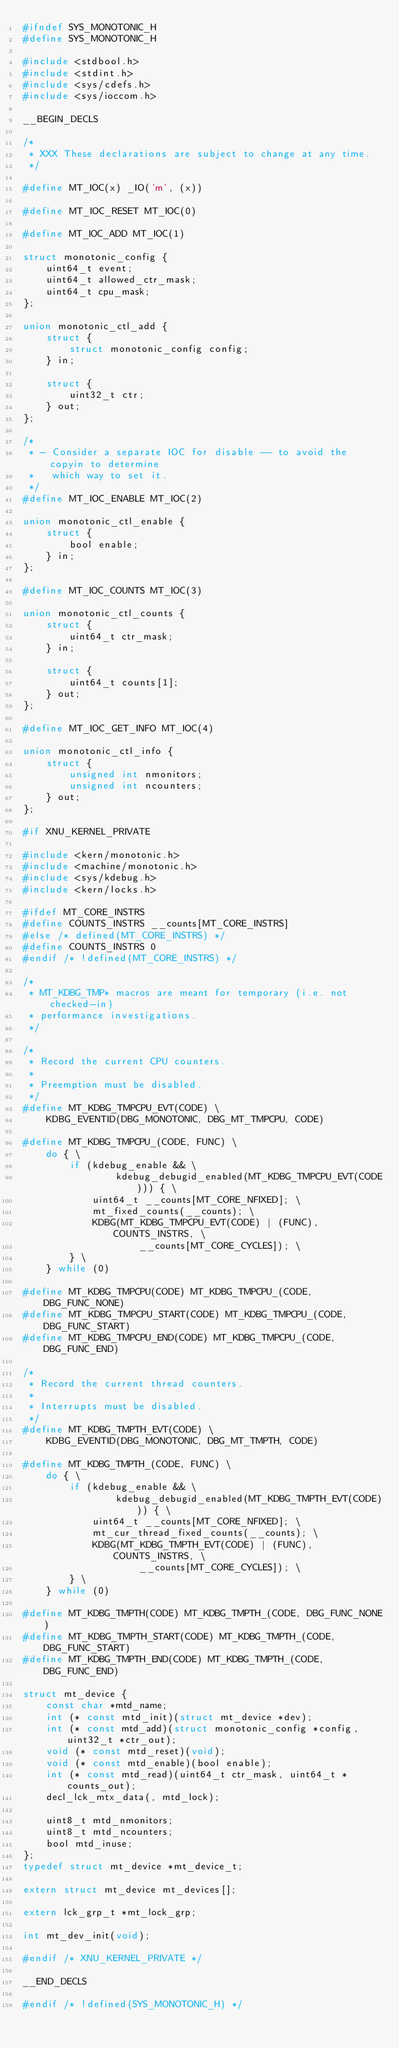Convert code to text. <code><loc_0><loc_0><loc_500><loc_500><_C_>#ifndef SYS_MONOTONIC_H
#define SYS_MONOTONIC_H

#include <stdbool.h>
#include <stdint.h>
#include <sys/cdefs.h>
#include <sys/ioccom.h>

__BEGIN_DECLS

/*
 * XXX These declarations are subject to change at any time.
 */

#define MT_IOC(x) _IO('m', (x))

#define MT_IOC_RESET MT_IOC(0)

#define MT_IOC_ADD MT_IOC(1)

struct monotonic_config {
	uint64_t event;
	uint64_t allowed_ctr_mask;
	uint64_t cpu_mask;
};

union monotonic_ctl_add {
	struct {
		struct monotonic_config config;
	} in;

	struct {
		uint32_t ctr;
	} out;
};

/*
 * - Consider a separate IOC for disable -- to avoid the copyin to determine
 *   which way to set it.
 */
#define MT_IOC_ENABLE MT_IOC(2)

union monotonic_ctl_enable {
	struct {
		bool enable;
	} in;
};

#define MT_IOC_COUNTS MT_IOC(3)

union monotonic_ctl_counts {
	struct {
		uint64_t ctr_mask;
	} in;

	struct {
		uint64_t counts[1];
	} out;
};

#define MT_IOC_GET_INFO MT_IOC(4)

union monotonic_ctl_info {
	struct {
		unsigned int nmonitors;
		unsigned int ncounters;
	} out;
};

#if XNU_KERNEL_PRIVATE

#include <kern/monotonic.h>
#include <machine/monotonic.h>
#include <sys/kdebug.h>
#include <kern/locks.h>

#ifdef MT_CORE_INSTRS
#define COUNTS_INSTRS __counts[MT_CORE_INSTRS]
#else /* defined(MT_CORE_INSTRS) */
#define COUNTS_INSTRS 0
#endif /* !defined(MT_CORE_INSTRS) */

/*
 * MT_KDBG_TMP* macros are meant for temporary (i.e. not checked-in)
 * performance investigations.
 */

/*
 * Record the current CPU counters.
 *
 * Preemption must be disabled.
 */
#define MT_KDBG_TMPCPU_EVT(CODE) \
	KDBG_EVENTID(DBG_MONOTONIC, DBG_MT_TMPCPU, CODE)

#define MT_KDBG_TMPCPU_(CODE, FUNC) \
	do { \
		if (kdebug_enable && \
				kdebug_debugid_enabled(MT_KDBG_TMPCPU_EVT(CODE))) { \
			uint64_t __counts[MT_CORE_NFIXED]; \
			mt_fixed_counts(__counts); \
			KDBG(MT_KDBG_TMPCPU_EVT(CODE) | (FUNC), COUNTS_INSTRS, \
					__counts[MT_CORE_CYCLES]); \
		} \
	} while (0)

#define MT_KDBG_TMPCPU(CODE) MT_KDBG_TMPCPU_(CODE, DBG_FUNC_NONE)
#define MT_KDBG_TMPCPU_START(CODE) MT_KDBG_TMPCPU_(CODE, DBG_FUNC_START)
#define MT_KDBG_TMPCPU_END(CODE) MT_KDBG_TMPCPU_(CODE, DBG_FUNC_END)

/*
 * Record the current thread counters.
 *
 * Interrupts must be disabled.
 */
#define MT_KDBG_TMPTH_EVT(CODE) \
	KDBG_EVENTID(DBG_MONOTONIC, DBG_MT_TMPTH, CODE)

#define MT_KDBG_TMPTH_(CODE, FUNC) \
	do { \
		if (kdebug_enable && \
				kdebug_debugid_enabled(MT_KDBG_TMPTH_EVT(CODE))) { \
			uint64_t __counts[MT_CORE_NFIXED]; \
			mt_cur_thread_fixed_counts(__counts); \
			KDBG(MT_KDBG_TMPTH_EVT(CODE) | (FUNC), COUNTS_INSTRS, \
					__counts[MT_CORE_CYCLES]); \
		} \
	} while (0)

#define MT_KDBG_TMPTH(CODE) MT_KDBG_TMPTH_(CODE, DBG_FUNC_NONE)
#define MT_KDBG_TMPTH_START(CODE) MT_KDBG_TMPTH_(CODE, DBG_FUNC_START)
#define MT_KDBG_TMPTH_END(CODE) MT_KDBG_TMPTH_(CODE, DBG_FUNC_END)

struct mt_device {
	const char *mtd_name;
	int (* const mtd_init)(struct mt_device *dev);
	int (* const mtd_add)(struct monotonic_config *config, uint32_t *ctr_out);
	void (* const mtd_reset)(void);
	void (* const mtd_enable)(bool enable);
	int (* const mtd_read)(uint64_t ctr_mask, uint64_t *counts_out);
	decl_lck_mtx_data(, mtd_lock);

	uint8_t mtd_nmonitors;
	uint8_t mtd_ncounters;
	bool mtd_inuse;
};
typedef struct mt_device *mt_device_t;

extern struct mt_device mt_devices[];

extern lck_grp_t *mt_lock_grp;

int mt_dev_init(void);

#endif /* XNU_KERNEL_PRIVATE */

__END_DECLS

#endif /* !defined(SYS_MONOTONIC_H) */
</code> 